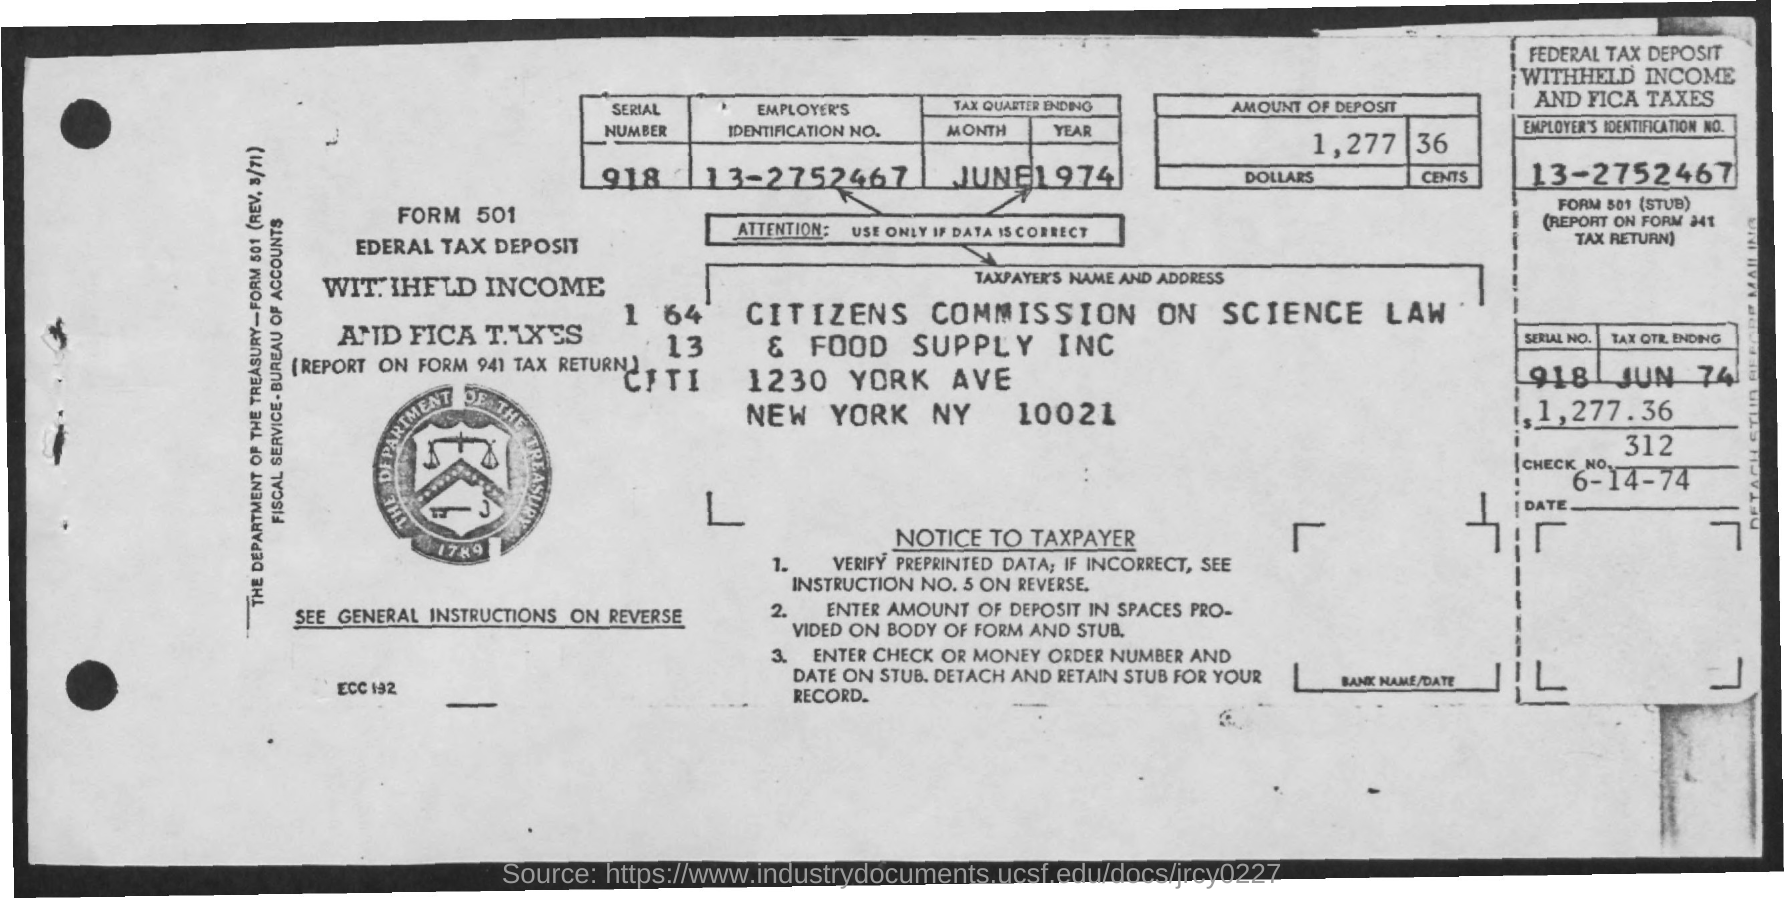Outline some significant characteristics in this image. The Employer's Identification Number is 13-2752467... The check number is 312. The serial number is 918... The form number is 501... 